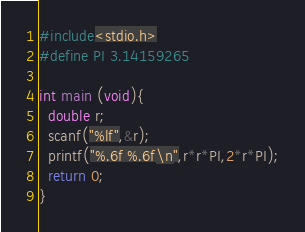Convert code to text. <code><loc_0><loc_0><loc_500><loc_500><_C_>#include<stdio.h>
#define PI 3.14159265

int main (void){
  double r;
  scanf("%lf",&r);
  printf("%.6f %.6f\n",r*r*PI,2*r*PI);
  return 0;
}</code> 